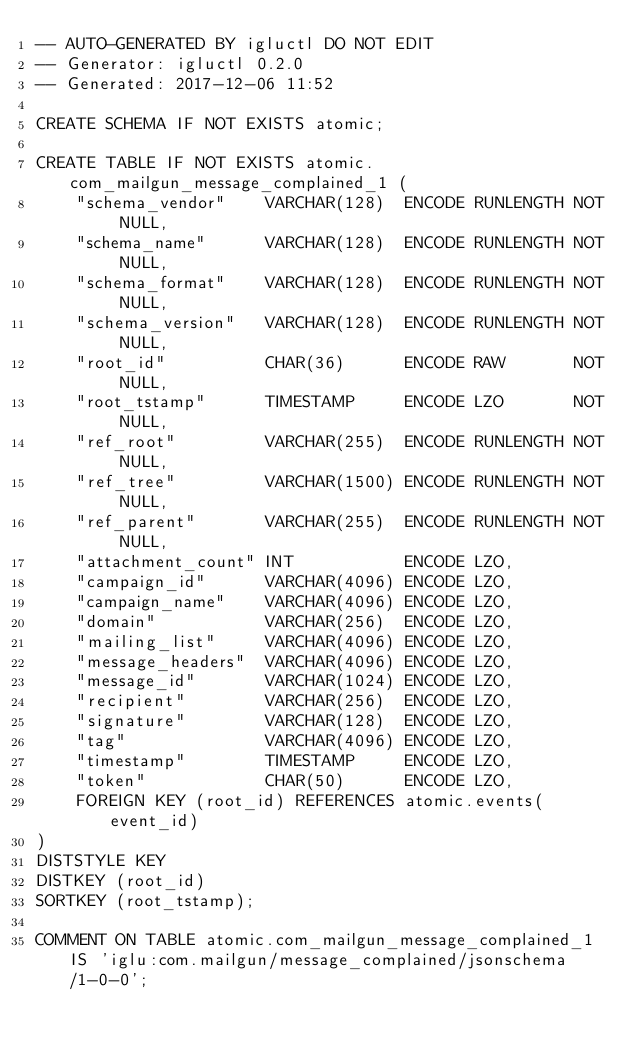Convert code to text. <code><loc_0><loc_0><loc_500><loc_500><_SQL_>-- AUTO-GENERATED BY igluctl DO NOT EDIT
-- Generator: igluctl 0.2.0
-- Generated: 2017-12-06 11:52

CREATE SCHEMA IF NOT EXISTS atomic;

CREATE TABLE IF NOT EXISTS atomic.com_mailgun_message_complained_1 (
    "schema_vendor"    VARCHAR(128)  ENCODE RUNLENGTH NOT NULL,
    "schema_name"      VARCHAR(128)  ENCODE RUNLENGTH NOT NULL,
    "schema_format"    VARCHAR(128)  ENCODE RUNLENGTH NOT NULL,
    "schema_version"   VARCHAR(128)  ENCODE RUNLENGTH NOT NULL,
    "root_id"          CHAR(36)      ENCODE RAW       NOT NULL,
    "root_tstamp"      TIMESTAMP     ENCODE LZO       NOT NULL,
    "ref_root"         VARCHAR(255)  ENCODE RUNLENGTH NOT NULL,
    "ref_tree"         VARCHAR(1500) ENCODE RUNLENGTH NOT NULL,
    "ref_parent"       VARCHAR(255)  ENCODE RUNLENGTH NOT NULL,
    "attachment_count" INT           ENCODE LZO,
    "campaign_id"      VARCHAR(4096) ENCODE LZO,
    "campaign_name"    VARCHAR(4096) ENCODE LZO,
    "domain"           VARCHAR(256)  ENCODE LZO,
    "mailing_list"     VARCHAR(4096) ENCODE LZO,
    "message_headers"  VARCHAR(4096) ENCODE LZO,
    "message_id"       VARCHAR(1024) ENCODE LZO,
    "recipient"        VARCHAR(256)  ENCODE LZO,
    "signature"        VARCHAR(128)  ENCODE LZO,
    "tag"              VARCHAR(4096) ENCODE LZO,
    "timestamp"        TIMESTAMP     ENCODE LZO,
    "token"            CHAR(50)      ENCODE LZO,
    FOREIGN KEY (root_id) REFERENCES atomic.events(event_id)
)
DISTSTYLE KEY
DISTKEY (root_id)
SORTKEY (root_tstamp);

COMMENT ON TABLE atomic.com_mailgun_message_complained_1 IS 'iglu:com.mailgun/message_complained/jsonschema/1-0-0';
</code> 